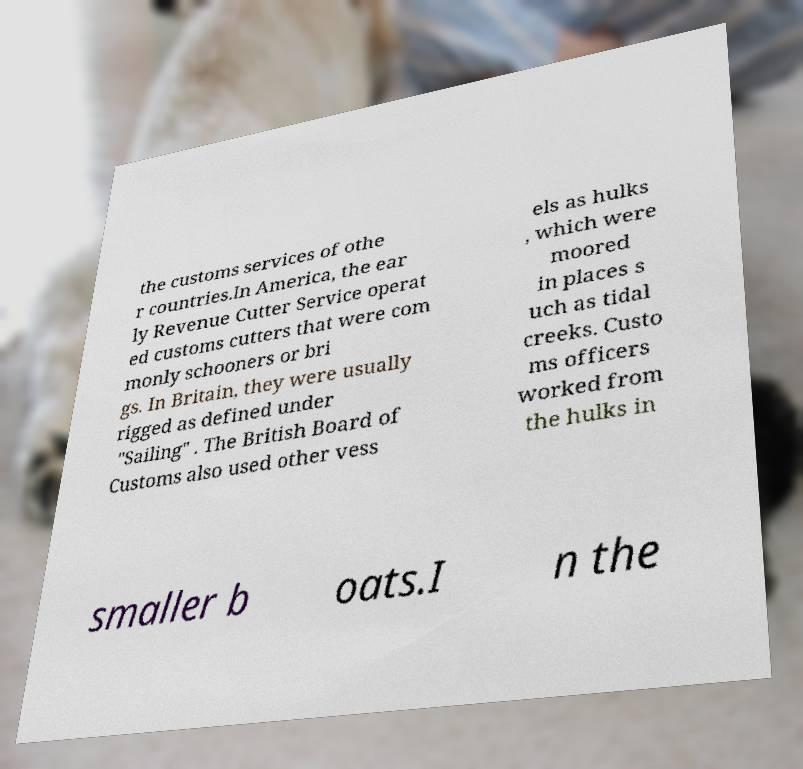Please read and relay the text visible in this image. What does it say? the customs services of othe r countries.In America, the ear ly Revenue Cutter Service operat ed customs cutters that were com monly schooners or bri gs. In Britain, they were usually rigged as defined under "Sailing" . The British Board of Customs also used other vess els as hulks , which were moored in places s uch as tidal creeks. Custo ms officers worked from the hulks in smaller b oats.I n the 